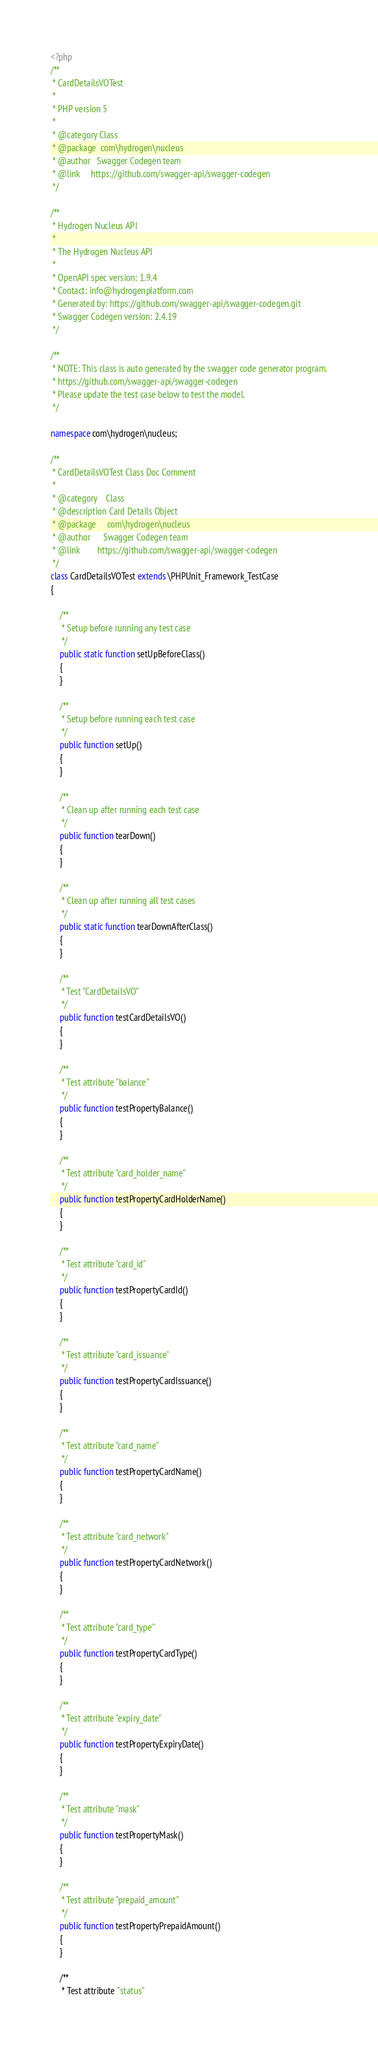<code> <loc_0><loc_0><loc_500><loc_500><_PHP_><?php
/**
 * CardDetailsVOTest
 *
 * PHP version 5
 *
 * @category Class
 * @package  com\hydrogen\nucleus
 * @author   Swagger Codegen team
 * @link     https://github.com/swagger-api/swagger-codegen
 */

/**
 * Hydrogen Nucleus API
 *
 * The Hydrogen Nucleus API
 *
 * OpenAPI spec version: 1.9.4
 * Contact: info@hydrogenplatform.com
 * Generated by: https://github.com/swagger-api/swagger-codegen.git
 * Swagger Codegen version: 2.4.19
 */

/**
 * NOTE: This class is auto generated by the swagger code generator program.
 * https://github.com/swagger-api/swagger-codegen
 * Please update the test case below to test the model.
 */

namespace com\hydrogen\nucleus;

/**
 * CardDetailsVOTest Class Doc Comment
 *
 * @category    Class
 * @description Card Details Object
 * @package     com\hydrogen\nucleus
 * @author      Swagger Codegen team
 * @link        https://github.com/swagger-api/swagger-codegen
 */
class CardDetailsVOTest extends \PHPUnit_Framework_TestCase
{

    /**
     * Setup before running any test case
     */
    public static function setUpBeforeClass()
    {
    }

    /**
     * Setup before running each test case
     */
    public function setUp()
    {
    }

    /**
     * Clean up after running each test case
     */
    public function tearDown()
    {
    }

    /**
     * Clean up after running all test cases
     */
    public static function tearDownAfterClass()
    {
    }

    /**
     * Test "CardDetailsVO"
     */
    public function testCardDetailsVO()
    {
    }

    /**
     * Test attribute "balance"
     */
    public function testPropertyBalance()
    {
    }

    /**
     * Test attribute "card_holder_name"
     */
    public function testPropertyCardHolderName()
    {
    }

    /**
     * Test attribute "card_id"
     */
    public function testPropertyCardId()
    {
    }

    /**
     * Test attribute "card_issuance"
     */
    public function testPropertyCardIssuance()
    {
    }

    /**
     * Test attribute "card_name"
     */
    public function testPropertyCardName()
    {
    }

    /**
     * Test attribute "card_network"
     */
    public function testPropertyCardNetwork()
    {
    }

    /**
     * Test attribute "card_type"
     */
    public function testPropertyCardType()
    {
    }

    /**
     * Test attribute "expiry_date"
     */
    public function testPropertyExpiryDate()
    {
    }

    /**
     * Test attribute "mask"
     */
    public function testPropertyMask()
    {
    }

    /**
     * Test attribute "prepaid_amount"
     */
    public function testPropertyPrepaidAmount()
    {
    }

    /**
     * Test attribute "status"</code> 